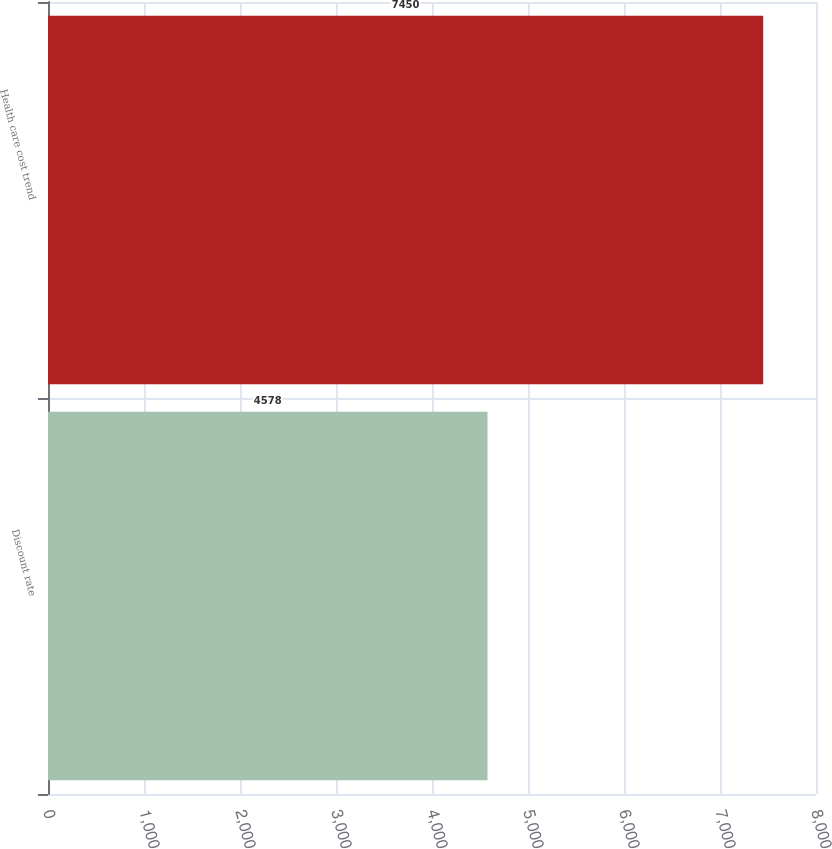<chart> <loc_0><loc_0><loc_500><loc_500><bar_chart><fcel>Discount rate<fcel>Health care cost trend<nl><fcel>4578<fcel>7450<nl></chart> 